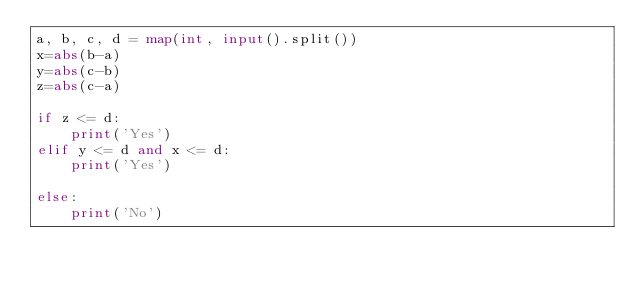<code> <loc_0><loc_0><loc_500><loc_500><_Python_>a, b, c, d = map(int, input().split())
x=abs(b-a)
y=abs(c-b)
z=abs(c-a)

if z <= d:
    print('Yes')
elif y <= d and x <= d:
    print('Yes')

else:
    print('No')</code> 